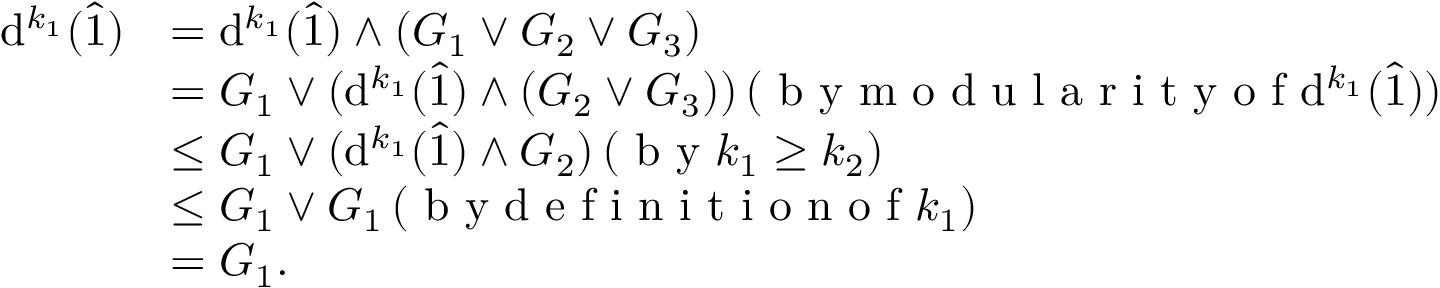Convert formula to latex. <formula><loc_0><loc_0><loc_500><loc_500>\begin{array} { r l } { d ^ { k _ { 1 } } ( \hat { 1 } ) } & { = d ^ { k _ { 1 } } ( \hat { 1 } ) \wedge ( G _ { 1 } \vee G _ { 2 } \vee G _ { 3 } ) } \\ & { = G _ { 1 } \vee ( d ^ { k _ { 1 } } ( \hat { 1 } ) \wedge ( G _ { 2 } \vee G _ { 3 } ) ) \, ( b y m o d u l a r i t y o f d ^ { k _ { 1 } } ( \hat { 1 } ) ) } \\ & { \leq G _ { 1 } \vee ( d ^ { k _ { 1 } } ( \hat { 1 } ) \wedge G _ { 2 } ) \, ( b y k _ { 1 } \geq k _ { 2 } ) } \\ & { \leq G _ { 1 } \vee G _ { 1 } \, ( b y d e f i n i t i o n o f k _ { 1 } ) } \\ & { = G _ { 1 } . } \end{array}</formula> 